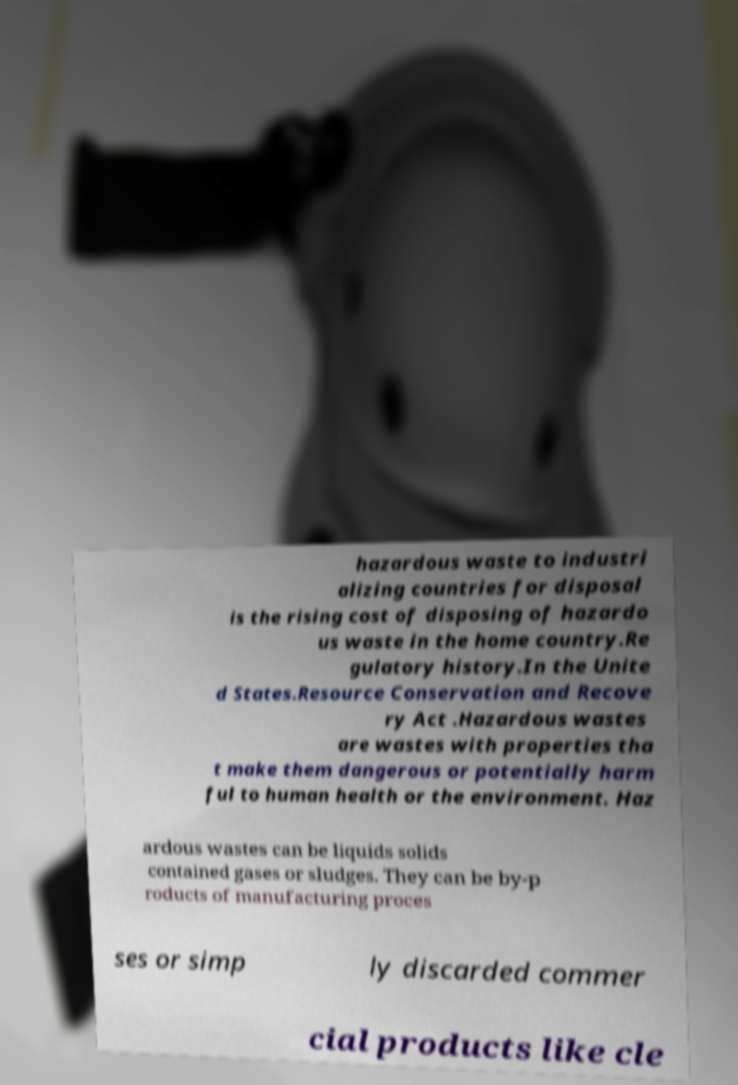What messages or text are displayed in this image? I need them in a readable, typed format. hazardous waste to industri alizing countries for disposal is the rising cost of disposing of hazardo us waste in the home country.Re gulatory history.In the Unite d States.Resource Conservation and Recove ry Act .Hazardous wastes are wastes with properties tha t make them dangerous or potentially harm ful to human health or the environment. Haz ardous wastes can be liquids solids contained gases or sludges. They can be by-p roducts of manufacturing proces ses or simp ly discarded commer cial products like cle 